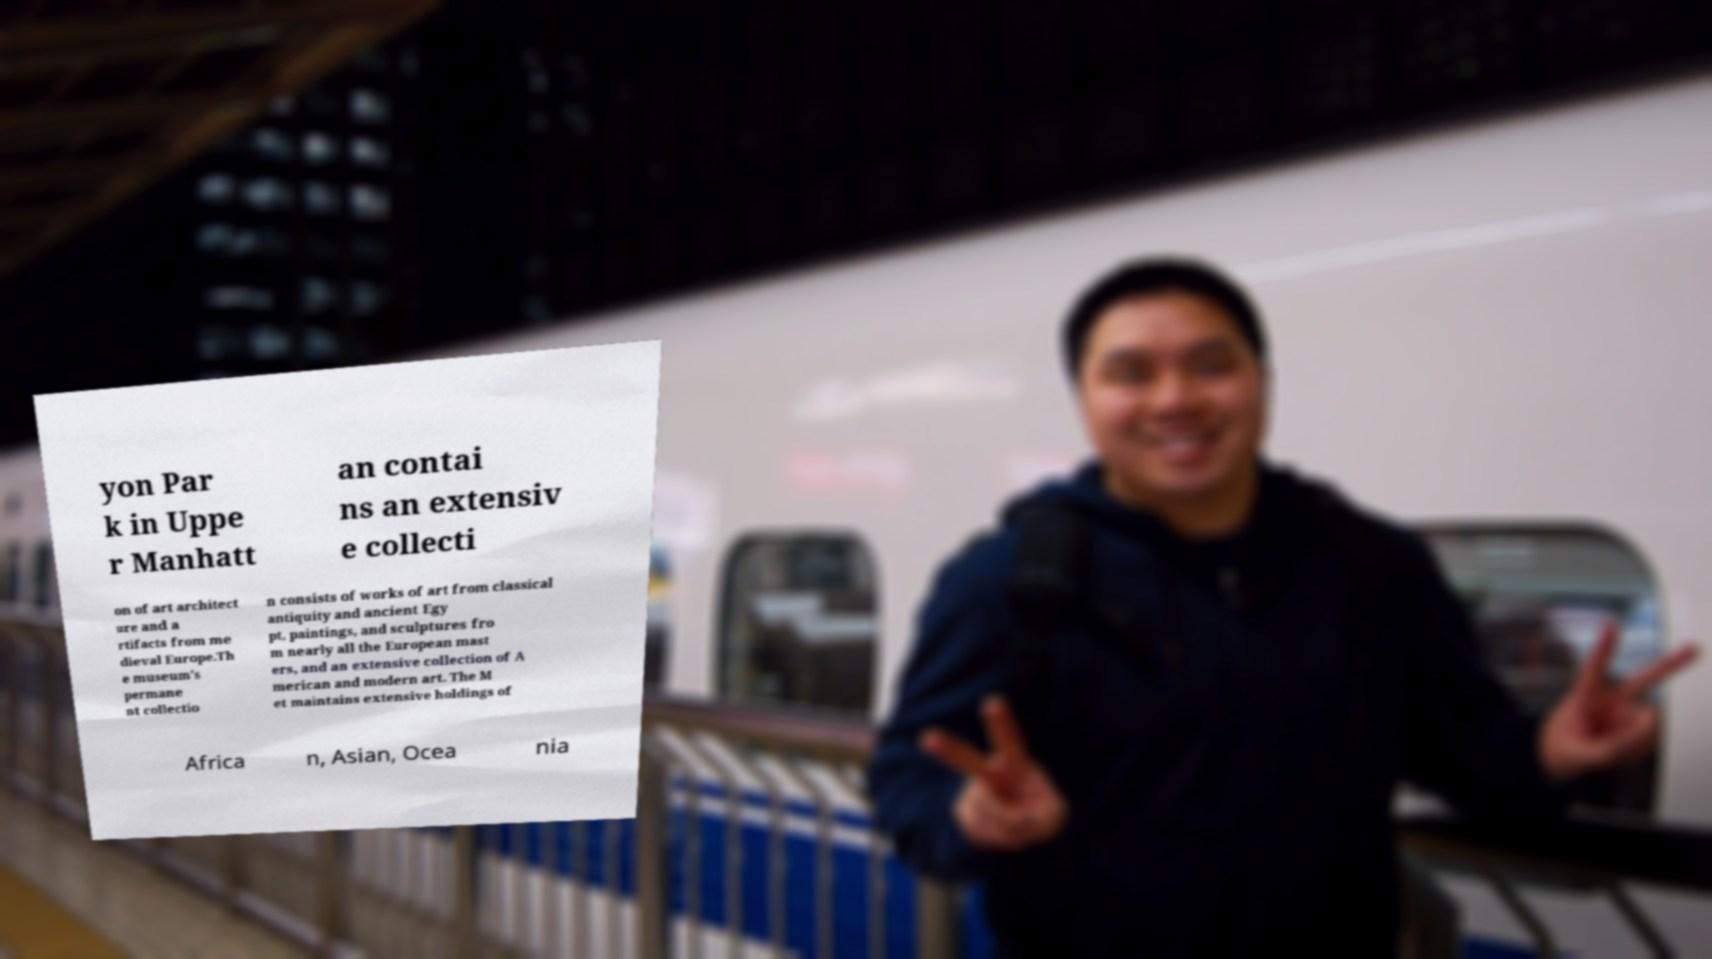Could you extract and type out the text from this image? yon Par k in Uppe r Manhatt an contai ns an extensiv e collecti on of art architect ure and a rtifacts from me dieval Europe.Th e museum's permane nt collectio n consists of works of art from classical antiquity and ancient Egy pt, paintings, and sculptures fro m nearly all the European mast ers, and an extensive collection of A merican and modern art. The M et maintains extensive holdings of Africa n, Asian, Ocea nia 